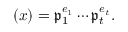Convert formula to latex. <formula><loc_0><loc_0><loc_500><loc_500>( x ) = { \mathfrak { p } } _ { 1 } ^ { e _ { 1 } } \cdots { \mathfrak { p } } _ { t } ^ { e _ { t } } .</formula> 